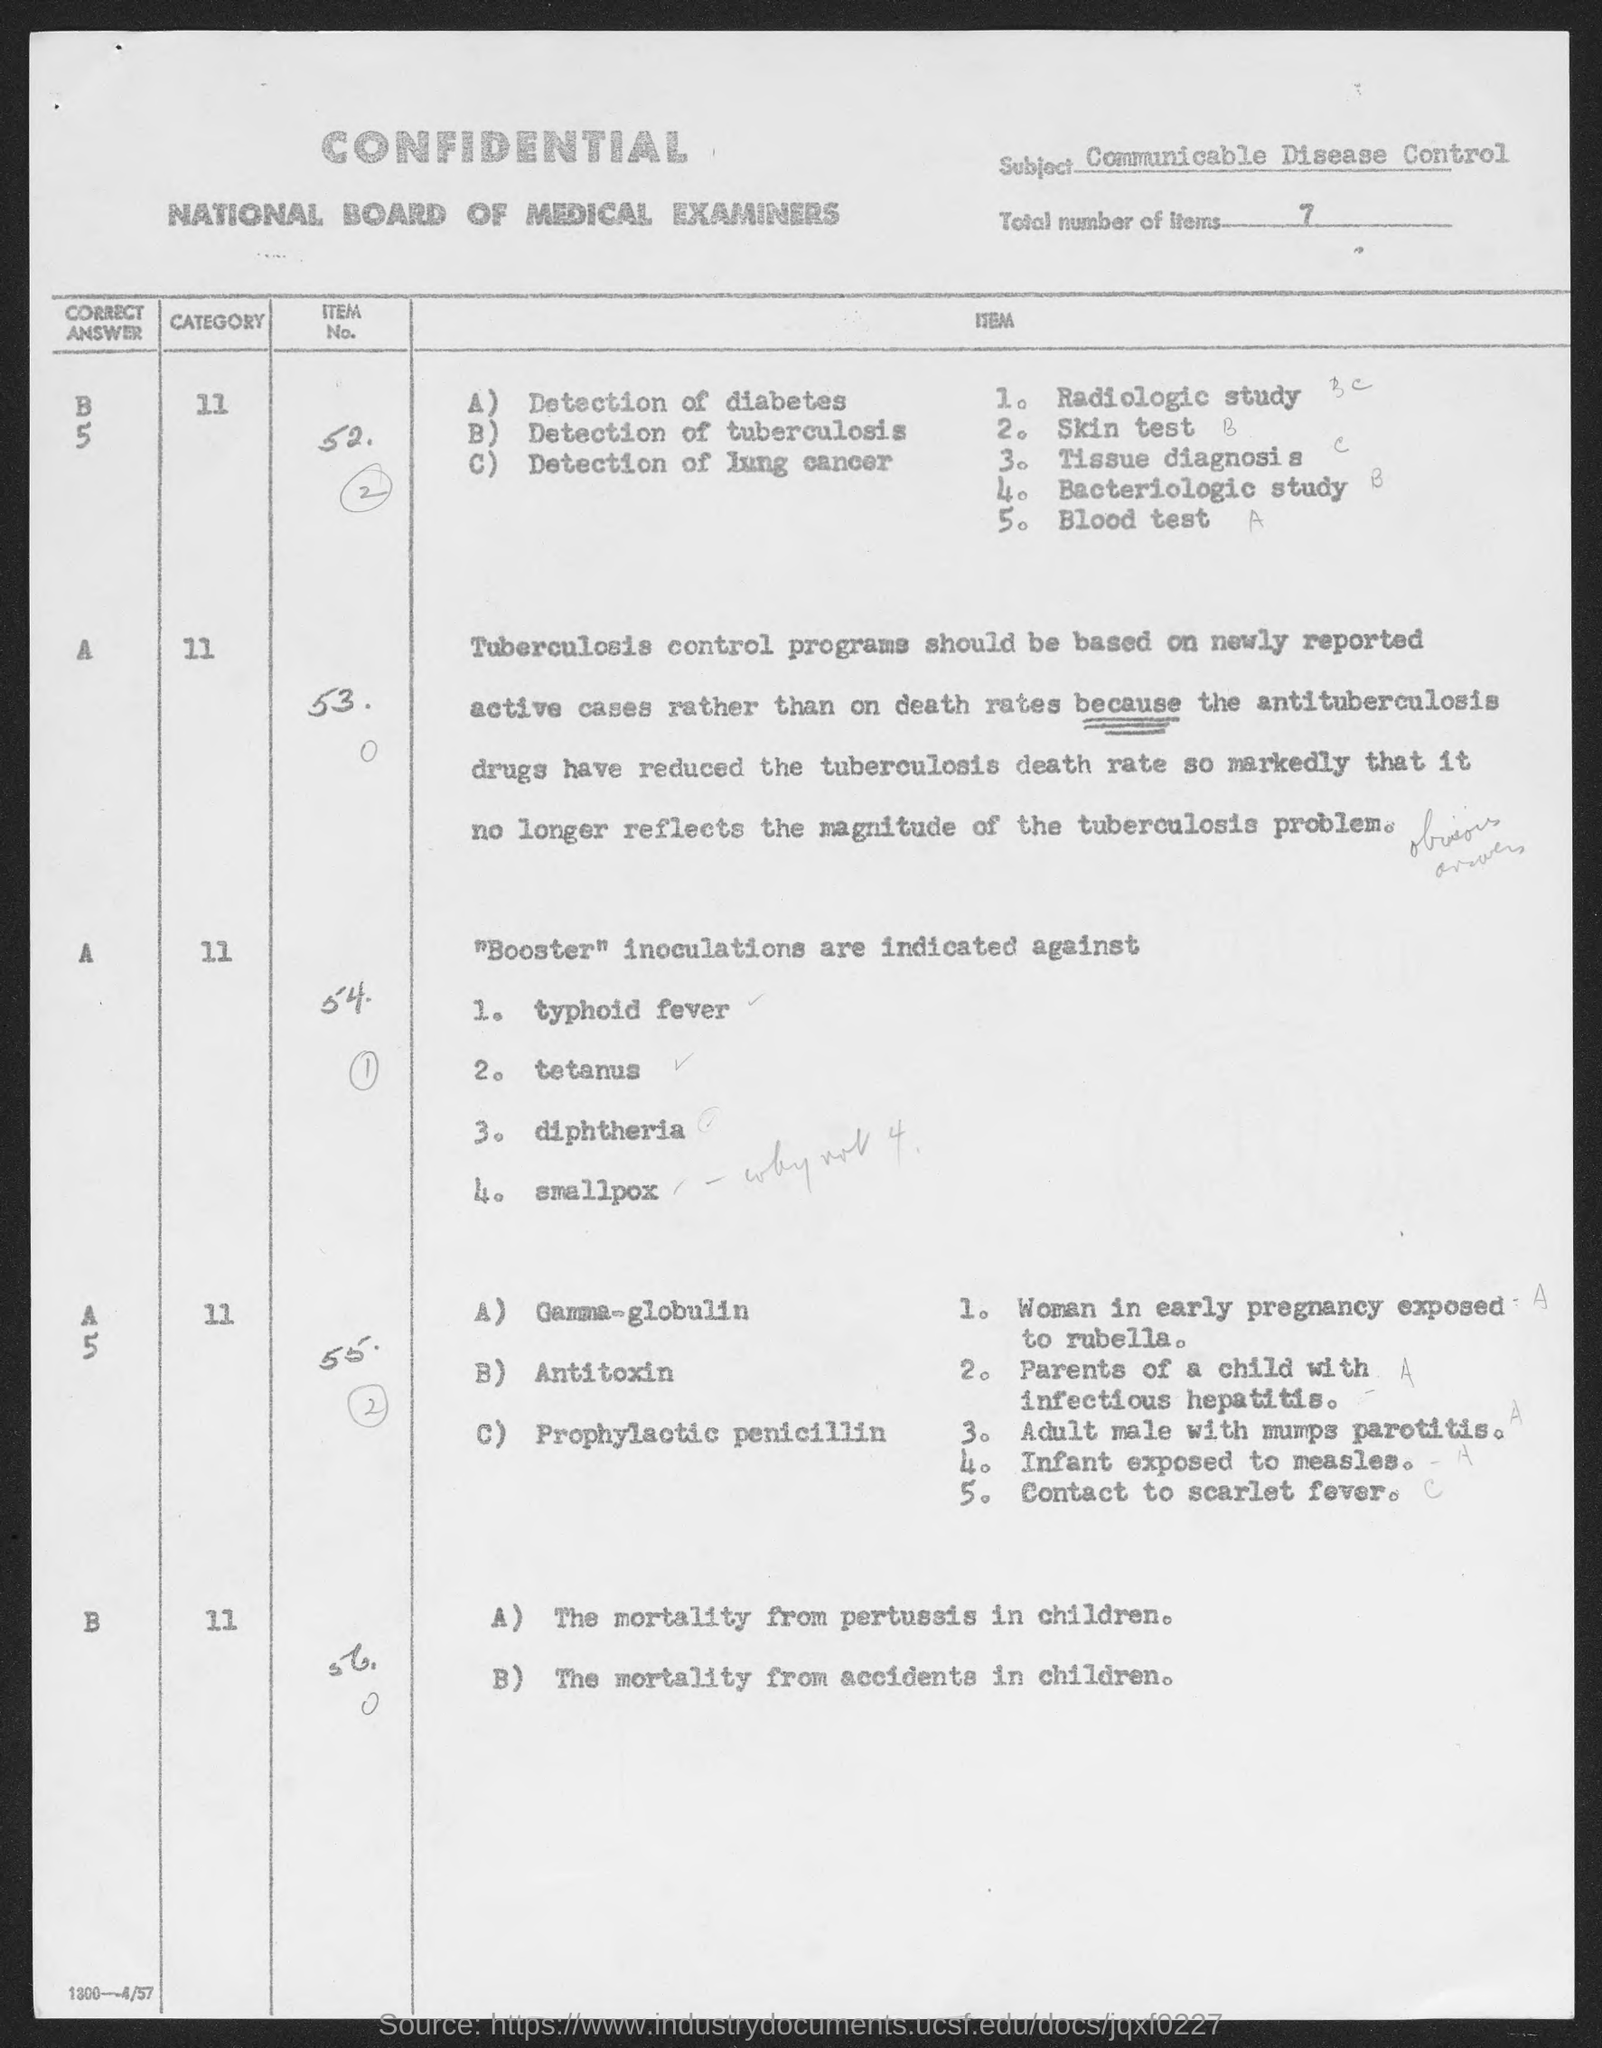What is the subject?
Offer a very short reply. Communicable Disease Control. What is the total number of Items?
Your answer should be very brief. 7. 